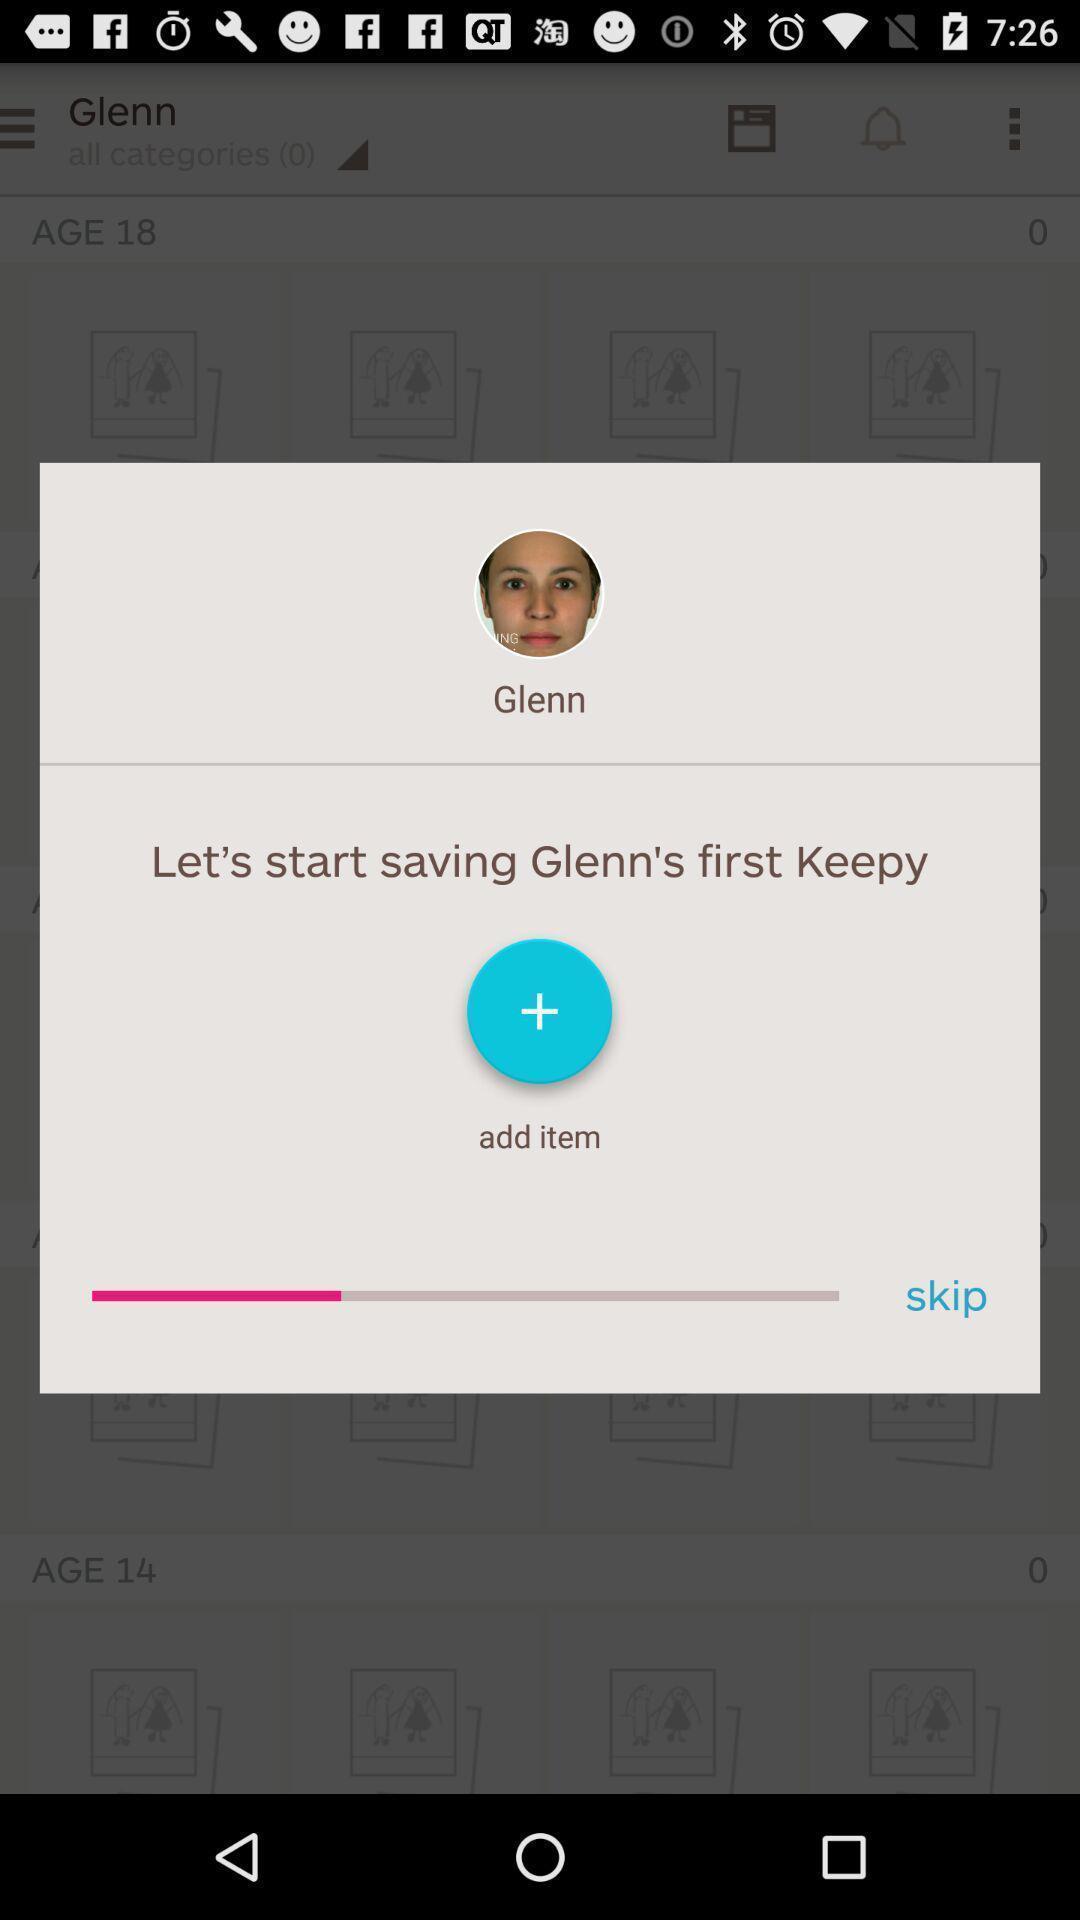Describe this image in words. Pop-up showing an option to add item. 